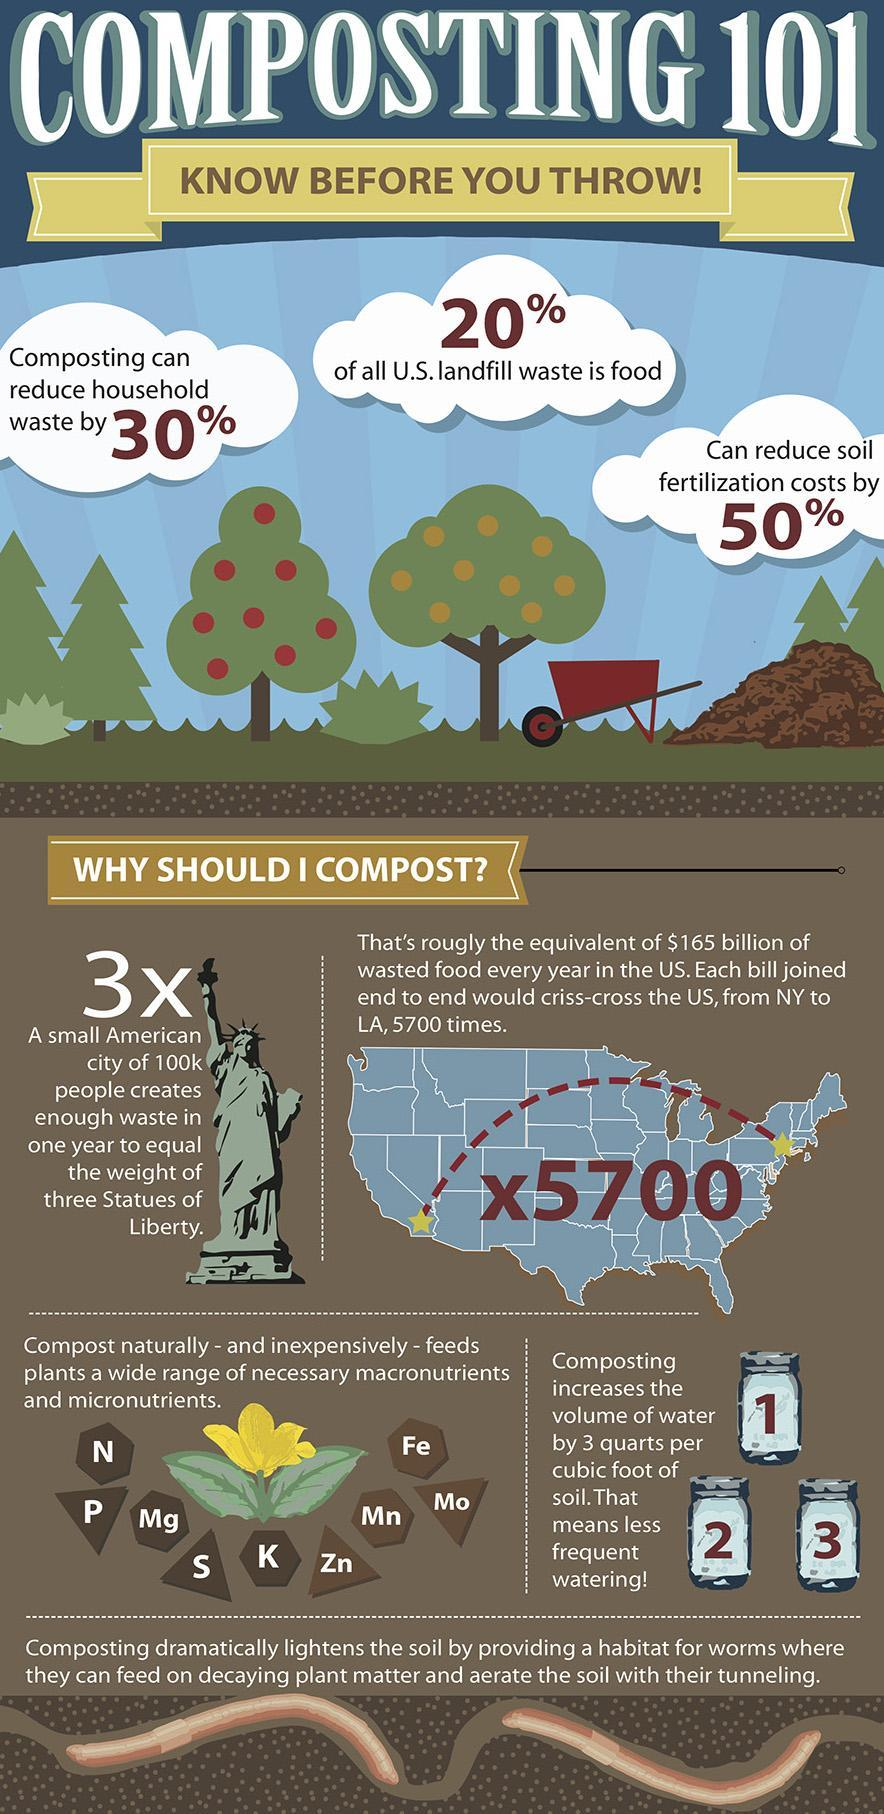Composting decreases what amount of soil propagation expenses?
Answer the question with a short phrase. 50% What is the expected wastage reduction through composting? 30% Which is the second micro nutrient listed in the infographic? Fe 